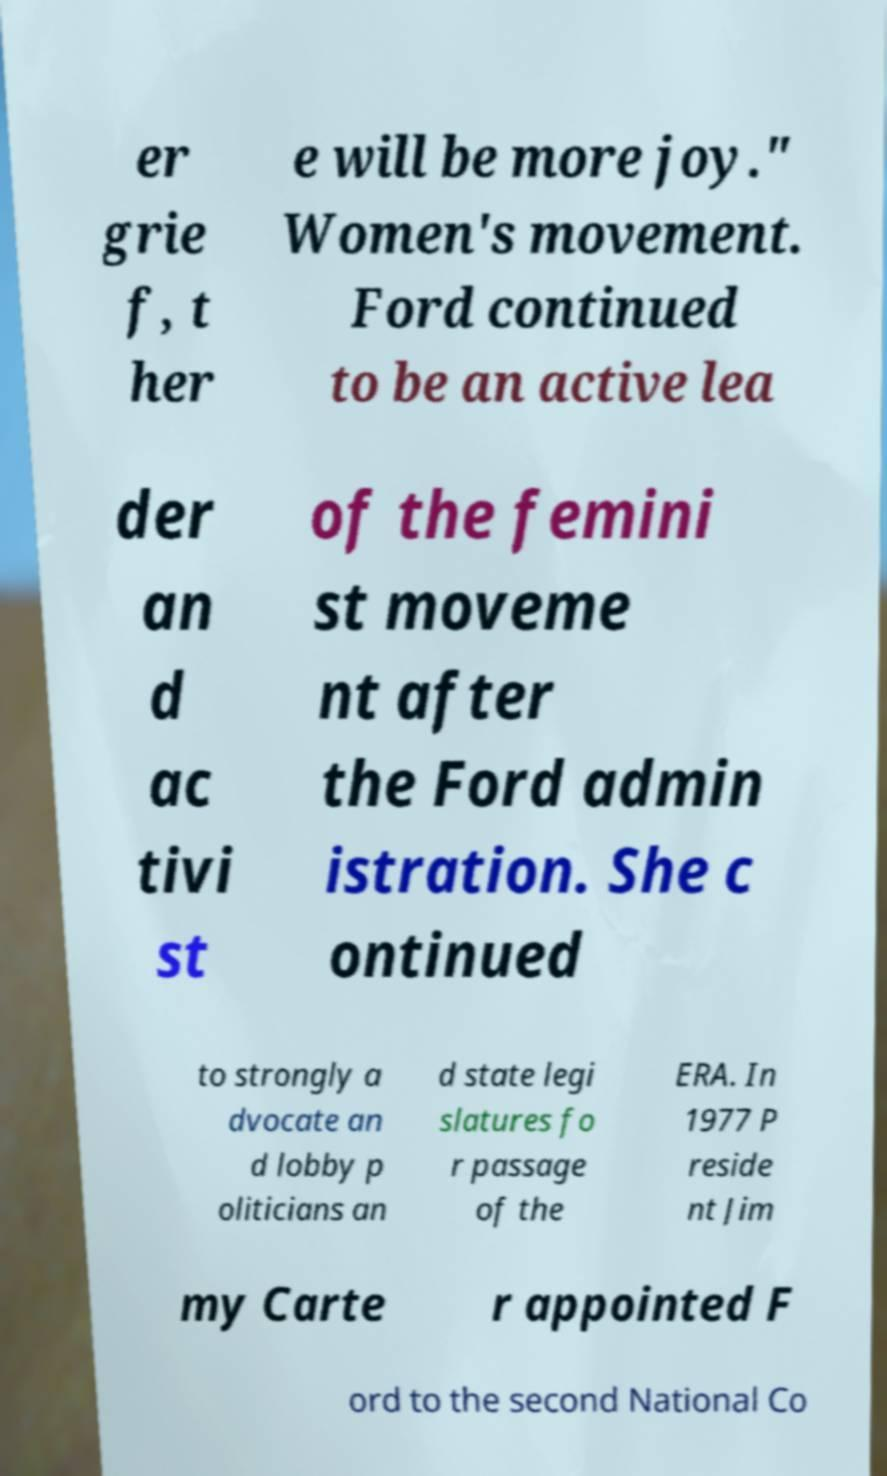Could you assist in decoding the text presented in this image and type it out clearly? er grie f, t her e will be more joy." Women's movement. Ford continued to be an active lea der an d ac tivi st of the femini st moveme nt after the Ford admin istration. She c ontinued to strongly a dvocate an d lobby p oliticians an d state legi slatures fo r passage of the ERA. In 1977 P reside nt Jim my Carte r appointed F ord to the second National Co 